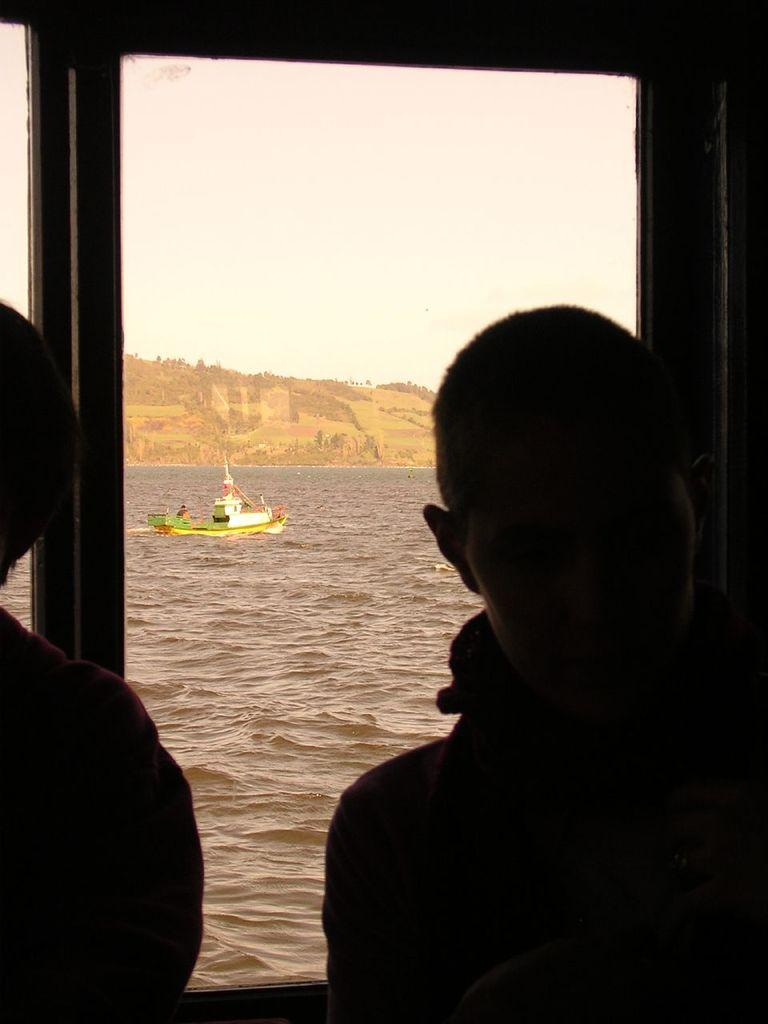How many people are in the image? There are two persons in the image. What is the lighting condition in the front of the image? The front of the image is a bit dark. What can be seen in the background of the image? There is a boat in the background of the image. What type of environment is visible in the image? There is water, land, and sky visible in the image. What language is being spoken by the persons in the image? There is no information about the language being spoken by the persons in the image. How many screws are visible in the image? There are no screws present in the image. 